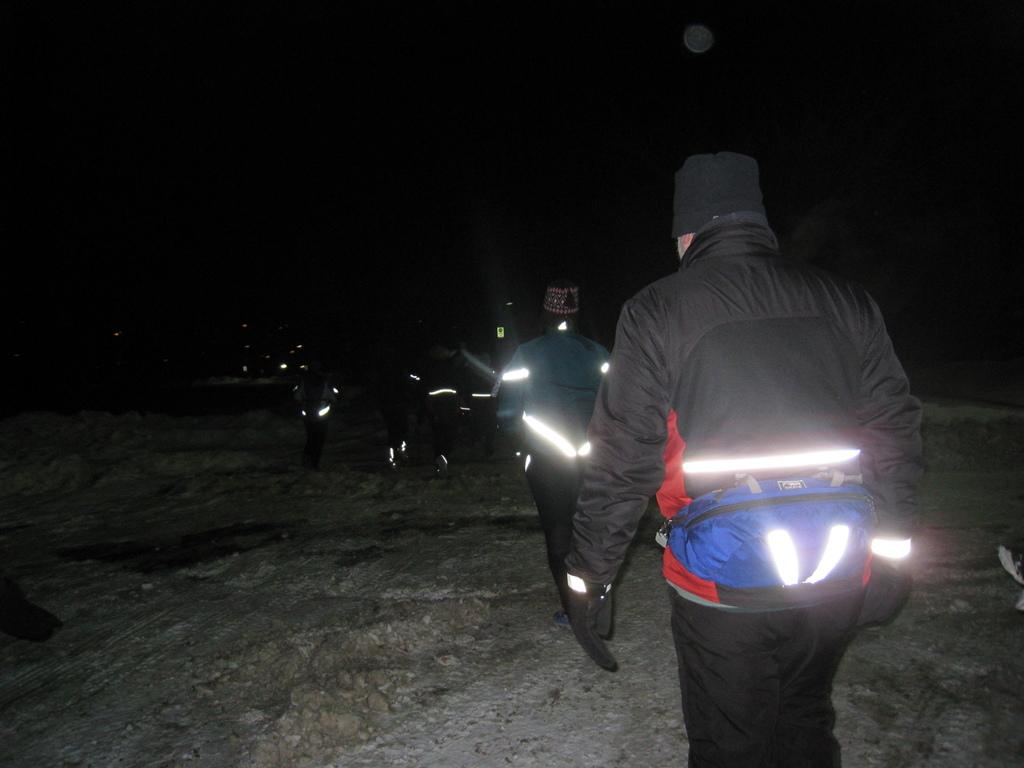Who or what is present in the image? There are people in the image. What are the people wearing on their heads? The people are wearing caps. What are the people wearing on their hands? The people are wearing gloves. What can be seen on the people's bodies? There are lights on the people. What can be observed about the background of the image? The background of the image is dark. What type of collar can be seen on the people in the image? There is no collar visible on the people in the image; they are wearing caps and gloves. 